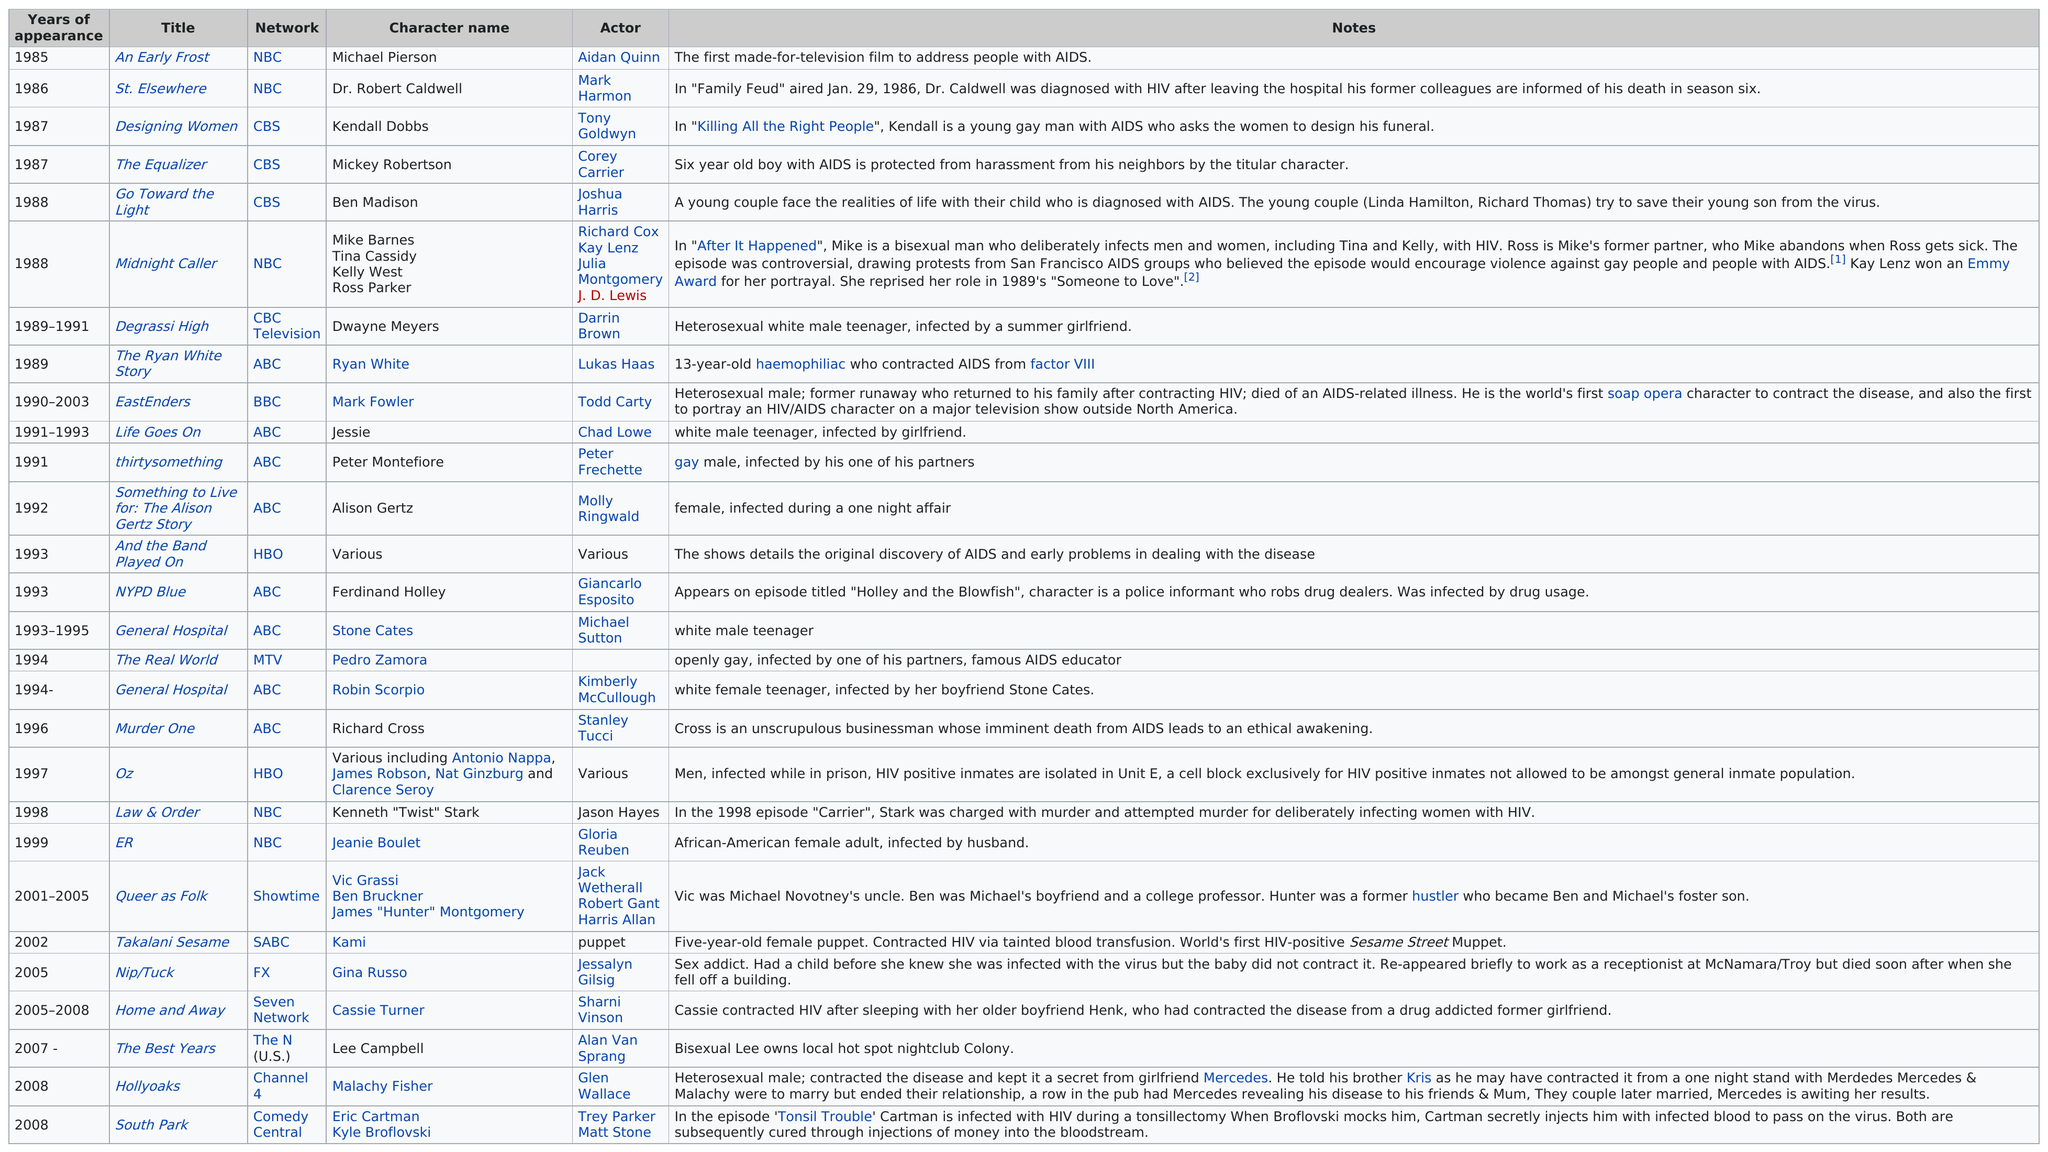List a handful of essential elements in this visual. Ryan White was the first character on ABC to be diagnosed with HIV. Out of the total number of shows that aired before 1992, 11 of them have been identified. An Early Frost," a television movie that openly discusses AIDS, is a significant film that raised awareness and challenged societal stigmas about the disease. According to the information provided, the total number of television programs aired by CBS involving characters with HIV is three. In total, HBO and MTV aired three shows collectively. 